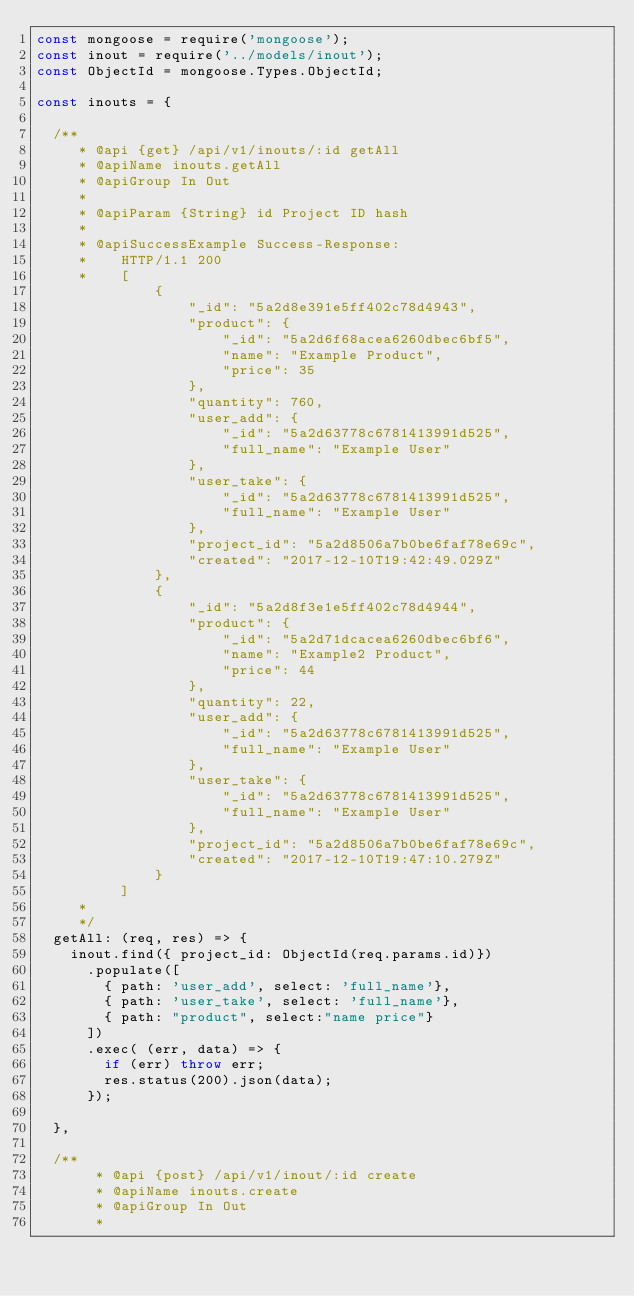Convert code to text. <code><loc_0><loc_0><loc_500><loc_500><_JavaScript_>const mongoose = require('mongoose');
const inout = require('../models/inout');
const ObjectId = mongoose.Types.ObjectId;

const inouts = {

  /**
     * @api {get} /api/v1/inouts/:id getAll
     * @apiName inouts.getAll
     * @apiGroup In Out
     *
     * @apiParam {String} id Project ID hash
     *
     * @apiSuccessExample Success-Response:
     *    HTTP/1.1 200
     *    [
              {
                  "_id": "5a2d8e391e5ff402c78d4943",
                  "product": {
                      "_id": "5a2d6f68acea6260dbec6bf5",
                      "name": "Example Product",
                      "price": 35
                  },
                  "quantity": 760,
                  "user_add": {
                      "_id": "5a2d63778c6781413991d525",
                      "full_name": "Example User"
                  },
                  "user_take": {
                      "_id": "5a2d63778c6781413991d525",
                      "full_name": "Example User"
                  },
                  "project_id": "5a2d8506a7b0be6faf78e69c",
                  "created": "2017-12-10T19:42:49.029Z"
              },
              {
                  "_id": "5a2d8f3e1e5ff402c78d4944",
                  "product": {
                      "_id": "5a2d71dcacea6260dbec6bf6",
                      "name": "Example2 Product",
                      "price": 44
                  },
                  "quantity": 22,
                  "user_add": {
                      "_id": "5a2d63778c6781413991d525",
                      "full_name": "Example User"
                  },
                  "user_take": {
                      "_id": "5a2d63778c6781413991d525",
                      "full_name": "Example User"
                  },
                  "project_id": "5a2d8506a7b0be6faf78e69c",
                  "created": "2017-12-10T19:47:10.279Z"
              }
          ]
     *
     */
  getAll: (req, res) => {
    inout.find({ project_id: ObjectId(req.params.id)})
      .populate([
        { path: 'user_add', select: 'full_name'},
        { path: 'user_take', select: 'full_name'},
        { path: "product", select:"name price"}
      ])
      .exec( (err, data) => {
        if (err) throw err;
        res.status(200).json(data);
      });

  },

  /**
       * @api {post} /api/v1/inout/:id create
       * @apiName inouts.create
       * @apiGroup In Out
       *</code> 